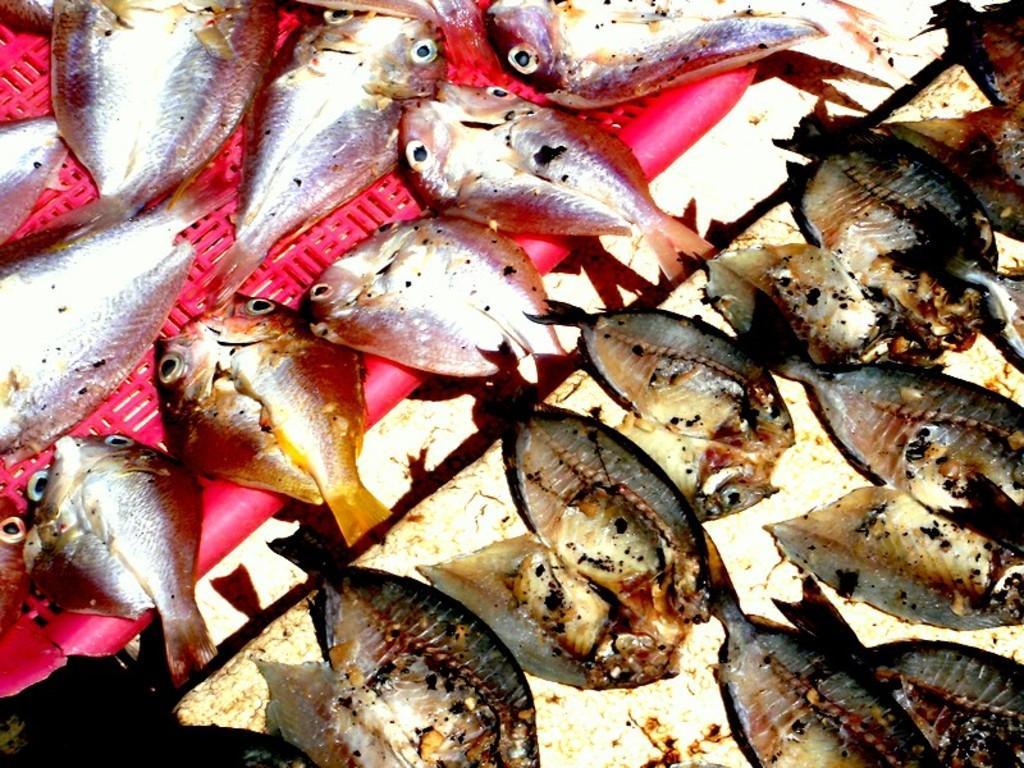Could you give a brief overview of what you see in this image? In this image in front there are fishes on the table. 